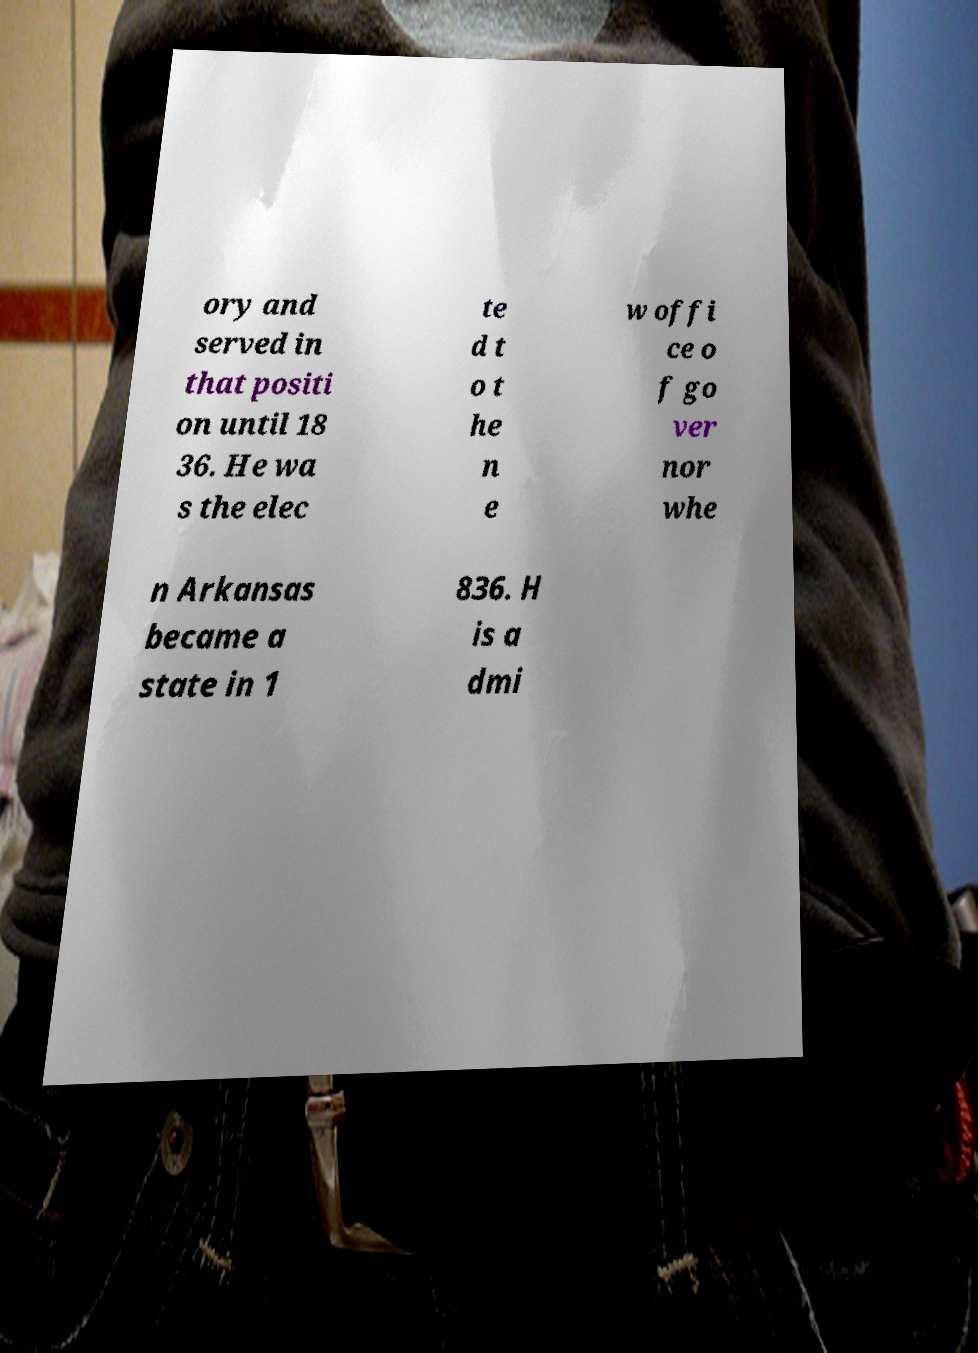I need the written content from this picture converted into text. Can you do that? ory and served in that positi on until 18 36. He wa s the elec te d t o t he n e w offi ce o f go ver nor whe n Arkansas became a state in 1 836. H is a dmi 